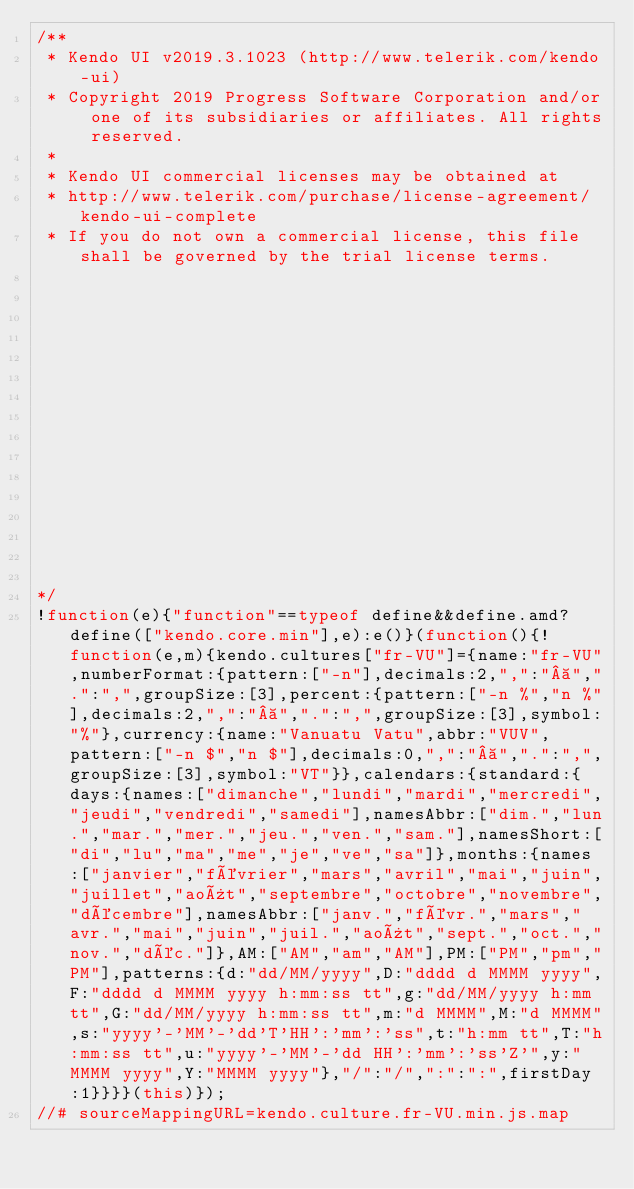<code> <loc_0><loc_0><loc_500><loc_500><_JavaScript_>/** 
 * Kendo UI v2019.3.1023 (http://www.telerik.com/kendo-ui)                                                                                                                                              
 * Copyright 2019 Progress Software Corporation and/or one of its subsidiaries or affiliates. All rights reserved.                                                                                      
 *                                                                                                                                                                                                      
 * Kendo UI commercial licenses may be obtained at                                                                                                                                                      
 * http://www.telerik.com/purchase/license-agreement/kendo-ui-complete                                                                                                                                  
 * If you do not own a commercial license, this file shall be governed by the trial license terms.                                                                                                      
                                                                                                                                                                                                       
                                                                                                                                                                                                       
                                                                                                                                                                                                       
                                                                                                                                                                                                       
                                                                                                                                                                                                       
                                                                                                                                                                                                       
                                                                                                                                                                                                       
                                                                                                                                                                                                       
                                                                                                                                                                                                       
                                                                                                                                                                                                       
                                                                                                                                                                                                       
                                                                                                                                                                                                       
                                                                                                                                                                                                       
                                                                                                                                                                                                       
                                                                                                                                                                                                       

*/
!function(e){"function"==typeof define&&define.amd?define(["kendo.core.min"],e):e()}(function(){!function(e,m){kendo.cultures["fr-VU"]={name:"fr-VU",numberFormat:{pattern:["-n"],decimals:2,",":" ",".":",",groupSize:[3],percent:{pattern:["-n %","n %"],decimals:2,",":" ",".":",",groupSize:[3],symbol:"%"},currency:{name:"Vanuatu Vatu",abbr:"VUV",pattern:["-n $","n $"],decimals:0,",":" ",".":",",groupSize:[3],symbol:"VT"}},calendars:{standard:{days:{names:["dimanche","lundi","mardi","mercredi","jeudi","vendredi","samedi"],namesAbbr:["dim.","lun.","mar.","mer.","jeu.","ven.","sam."],namesShort:["di","lu","ma","me","je","ve","sa"]},months:{names:["janvier","février","mars","avril","mai","juin","juillet","août","septembre","octobre","novembre","décembre"],namesAbbr:["janv.","févr.","mars","avr.","mai","juin","juil.","août","sept.","oct.","nov.","déc."]},AM:["AM","am","AM"],PM:["PM","pm","PM"],patterns:{d:"dd/MM/yyyy",D:"dddd d MMMM yyyy",F:"dddd d MMMM yyyy h:mm:ss tt",g:"dd/MM/yyyy h:mm tt",G:"dd/MM/yyyy h:mm:ss tt",m:"d MMMM",M:"d MMMM",s:"yyyy'-'MM'-'dd'T'HH':'mm':'ss",t:"h:mm tt",T:"h:mm:ss tt",u:"yyyy'-'MM'-'dd HH':'mm':'ss'Z'",y:"MMMM yyyy",Y:"MMMM yyyy"},"/":"/",":":":",firstDay:1}}}}(this)});
//# sourceMappingURL=kendo.culture.fr-VU.min.js.map
</code> 